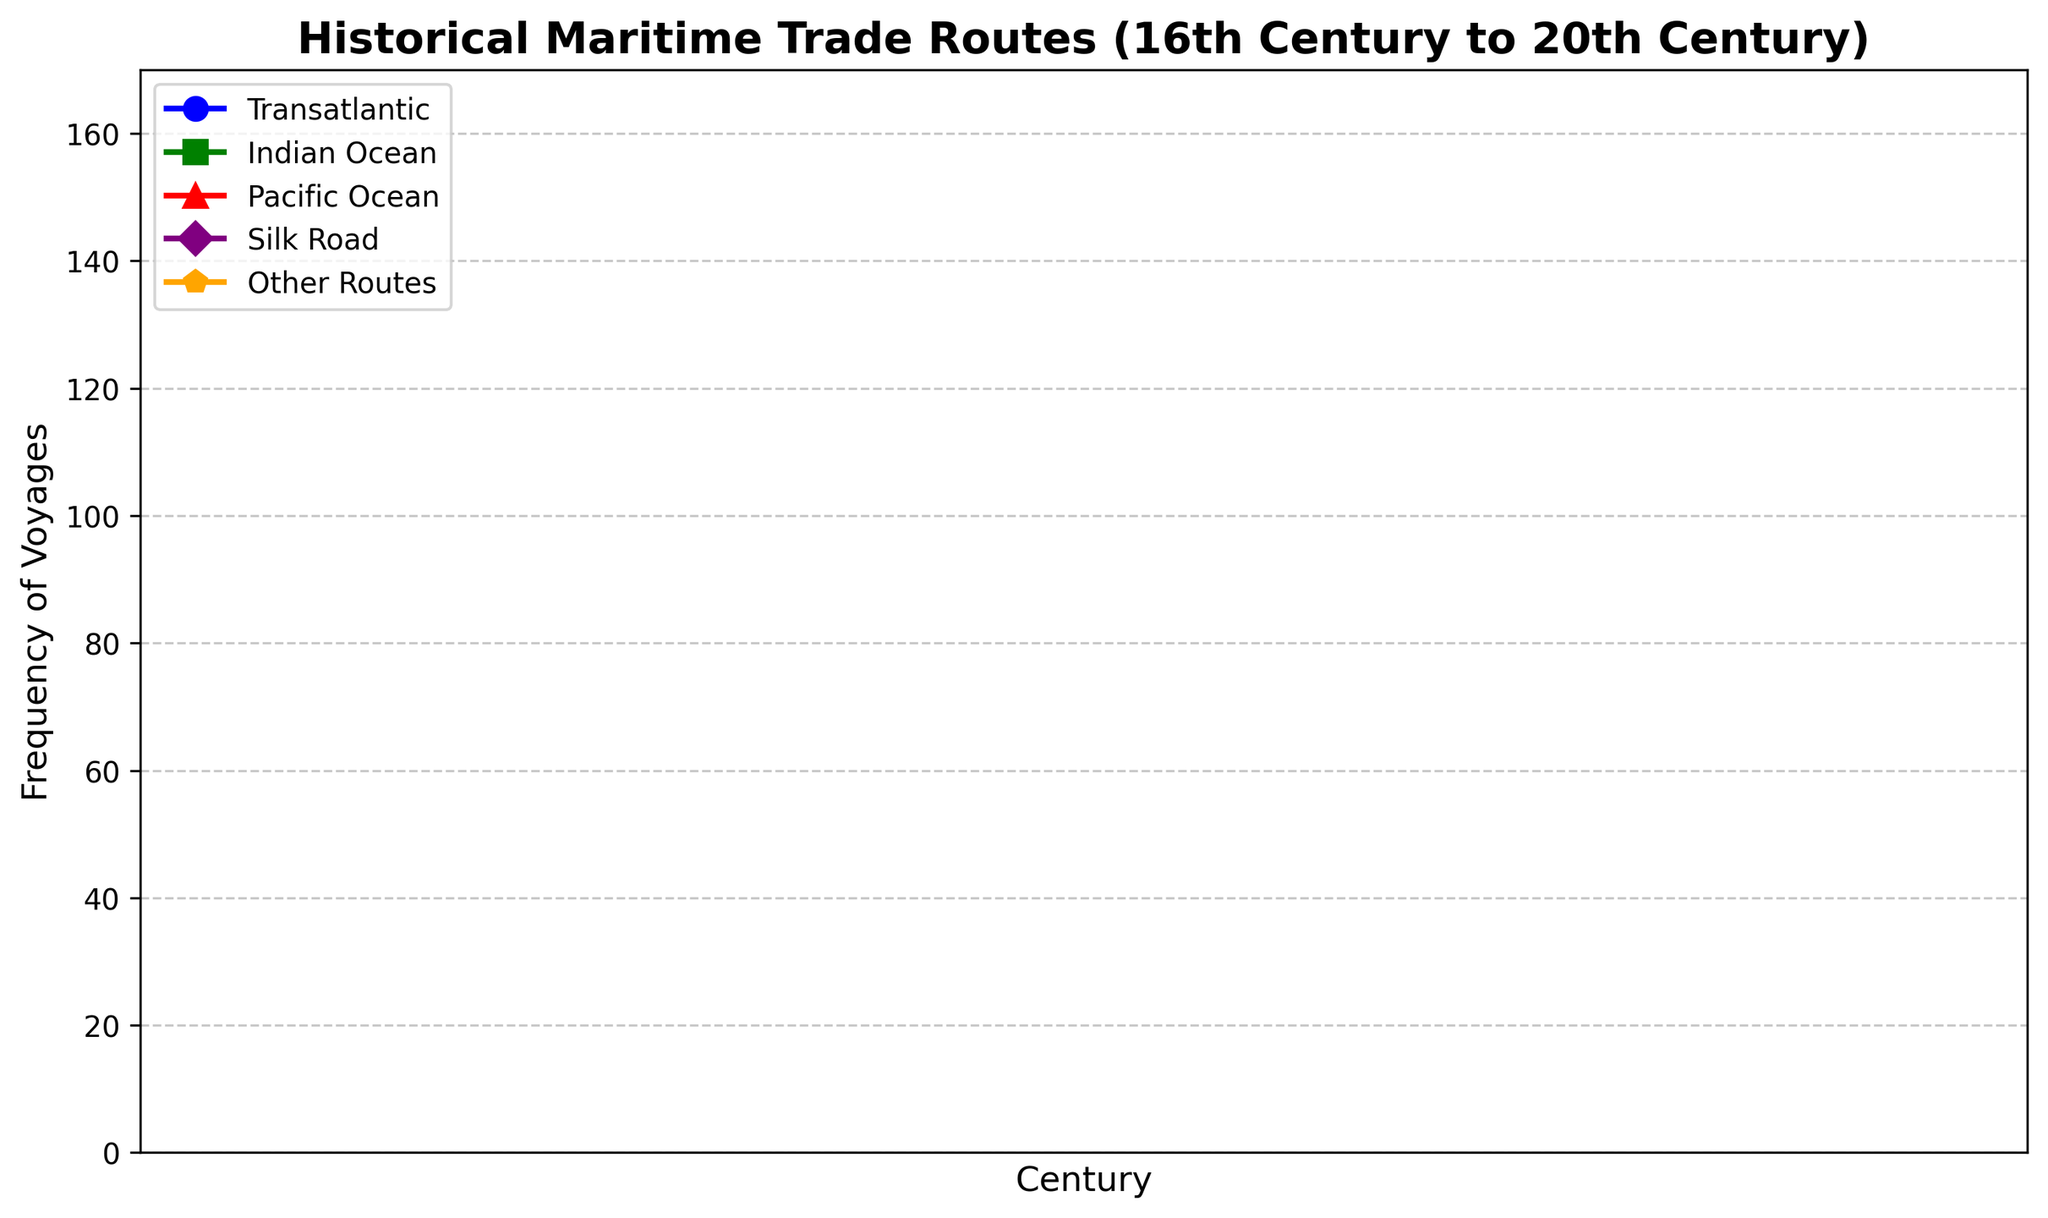What century saw the highest frequency of voyages on the Transatlantic route? The highest point on the Transatlantic line corresponds to the 1900s, with the frequency of voyages reaching 120.
Answer: 1900s Which maritime trade route had the least increase in frequency of voyages from the 1500s to the 1900s? Comparing the change in frequency from the 1500s to the 1900s: Transatlantic (120-0=120), Indian Ocean (150-30=120), Pacific Ocean (60-5=55), Silk Road (60-40=20), Other Routes (70-10=60). The Silk Road had the least increase.
Answer: Silk Road What was the frequency of voyages on the Indian Ocean and Pacific Ocean routes combined in the 1800s? The frequency for the Indian Ocean in the 1800s is 100, and for the Pacific Ocean, it is 40. Combined, this is 100 + 40 = 140.
Answer: 140 What is the difference in the frequency of voyages between the Transatlantic and Indian Ocean routes in the 1900s? In the 1900s, the Transatlantic route had 120 voyages, while the Indian Ocean had 150 voyages. The difference is 150 - 120 = 30.
Answer: 30 Which trade route showed a consistent increase in voyage frequency in each successive century? By examining the lines for each route, both the Transatlantic and Indian Ocean routes show a consistent increase every century.
Answer: Transatlantic and Indian Ocean In which century did the Silk Road have its highest frequency of voyages? The highest point on the Silk Road line corresponds to the 1900s, with the frequency of voyages being 60.
Answer: 1900s Between the 1500s and the 1700s, which route had the largest proportional increase in frequency of voyages? Proportional increase = (Frequency in 1700s - Frequency in 1500s) / Frequency in 1500s.
For Transatlantic: (40-0)/0, infinite.
For Indian Ocean: (70-30)/30 = 1.33.
For Pacific Ocean: (25-5)/5 = 4.
For Silk Road: (50-40)/40 = 0.25.
For Other Routes: (30-10)/10 = 2.
Ignoring zero-initial value routes, the Pacific Ocean had the largest proportional increase, with 4 times.
Answer: Pacific Ocean How does the frequency of voyages in the 1600s for the Other Routes compare to that of the Transatlantic in the 1800s? The Other Routes in the 1600s had 20 voyages, while the Transatlantic in the 1800s had 80 voyages. 80 is greater than 20.
Answer: Transatlantic in the 1800s is greater What color is used to represent the Pacific Ocean route on the chart? The line representing the Pacific Ocean route is colored red.
Answer: Red What is the average frequency of voyages on the Indian Ocean route across all centuries? The frequencies for the Indian Ocean are 30 (1500s), 50 (1600s), 70 (1700s), 100 (1800s), and 150 (1900s). The sum is 30+50+70+100+150 = 400. The average is 400 / 5 = 80.
Answer: 80 